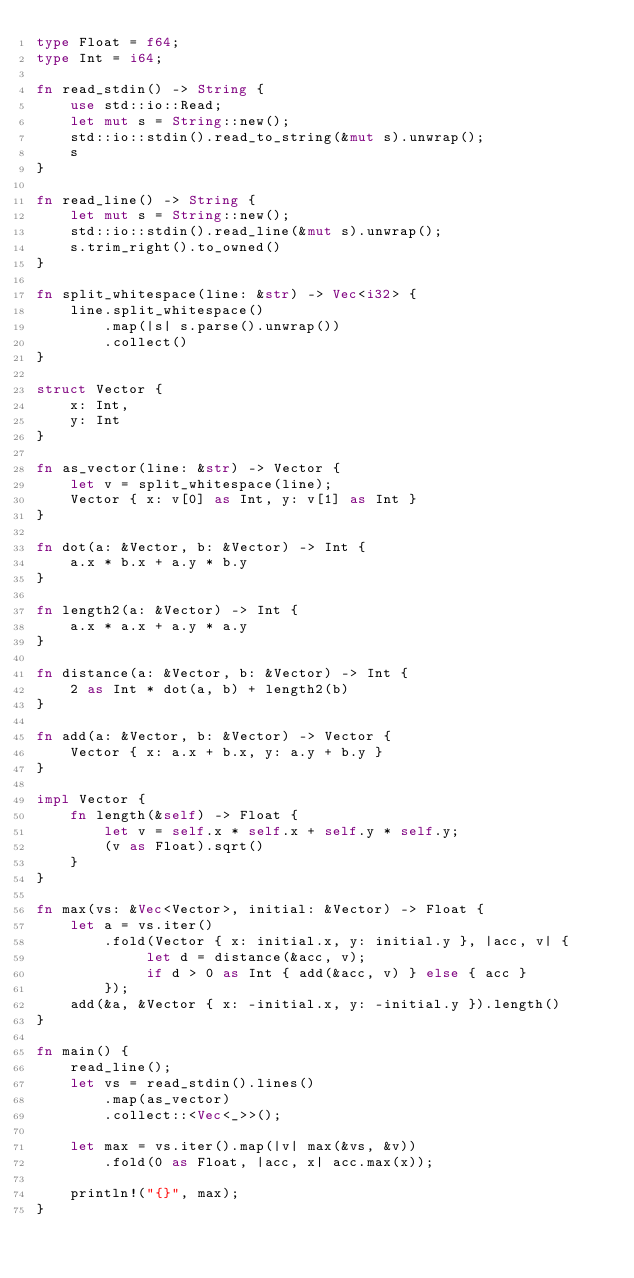<code> <loc_0><loc_0><loc_500><loc_500><_Rust_>type Float = f64;
type Int = i64;

fn read_stdin() -> String {
    use std::io::Read;
    let mut s = String::new();
    std::io::stdin().read_to_string(&mut s).unwrap();
    s
}
 
fn read_line() -> String {
    let mut s = String::new();
    std::io::stdin().read_line(&mut s).unwrap();
    s.trim_right().to_owned()
}
 
fn split_whitespace(line: &str) -> Vec<i32> {
    line.split_whitespace()
        .map(|s| s.parse().unwrap())
        .collect()
}

struct Vector {
    x: Int,
    y: Int
}

fn as_vector(line: &str) -> Vector {
    let v = split_whitespace(line);
    Vector { x: v[0] as Int, y: v[1] as Int }
}

fn dot(a: &Vector, b: &Vector) -> Int {
    a.x * b.x + a.y * b.y
}

fn length2(a: &Vector) -> Int {
    a.x * a.x + a.y * a.y
}

fn distance(a: &Vector, b: &Vector) -> Int {
    2 as Int * dot(a, b) + length2(b)
}

fn add(a: &Vector, b: &Vector) -> Vector {
    Vector { x: a.x + b.x, y: a.y + b.y }
}

impl Vector {
    fn length(&self) -> Float {
        let v = self.x * self.x + self.y * self.y;
        (v as Float).sqrt()
    }
}

fn max(vs: &Vec<Vector>, initial: &Vector) -> Float {
    let a = vs.iter()
        .fold(Vector { x: initial.x, y: initial.y }, |acc, v| {
             let d = distance(&acc, v);
             if d > 0 as Int { add(&acc, v) } else { acc }
        });
    add(&a, &Vector { x: -initial.x, y: -initial.y }).length()
}

fn main() {
    read_line();
    let vs = read_stdin().lines()
        .map(as_vector)
        .collect::<Vec<_>>();
        
    let max = vs.iter().map(|v| max(&vs, &v))
        .fold(0 as Float, |acc, x| acc.max(x));
 
    println!("{}", max);
}</code> 